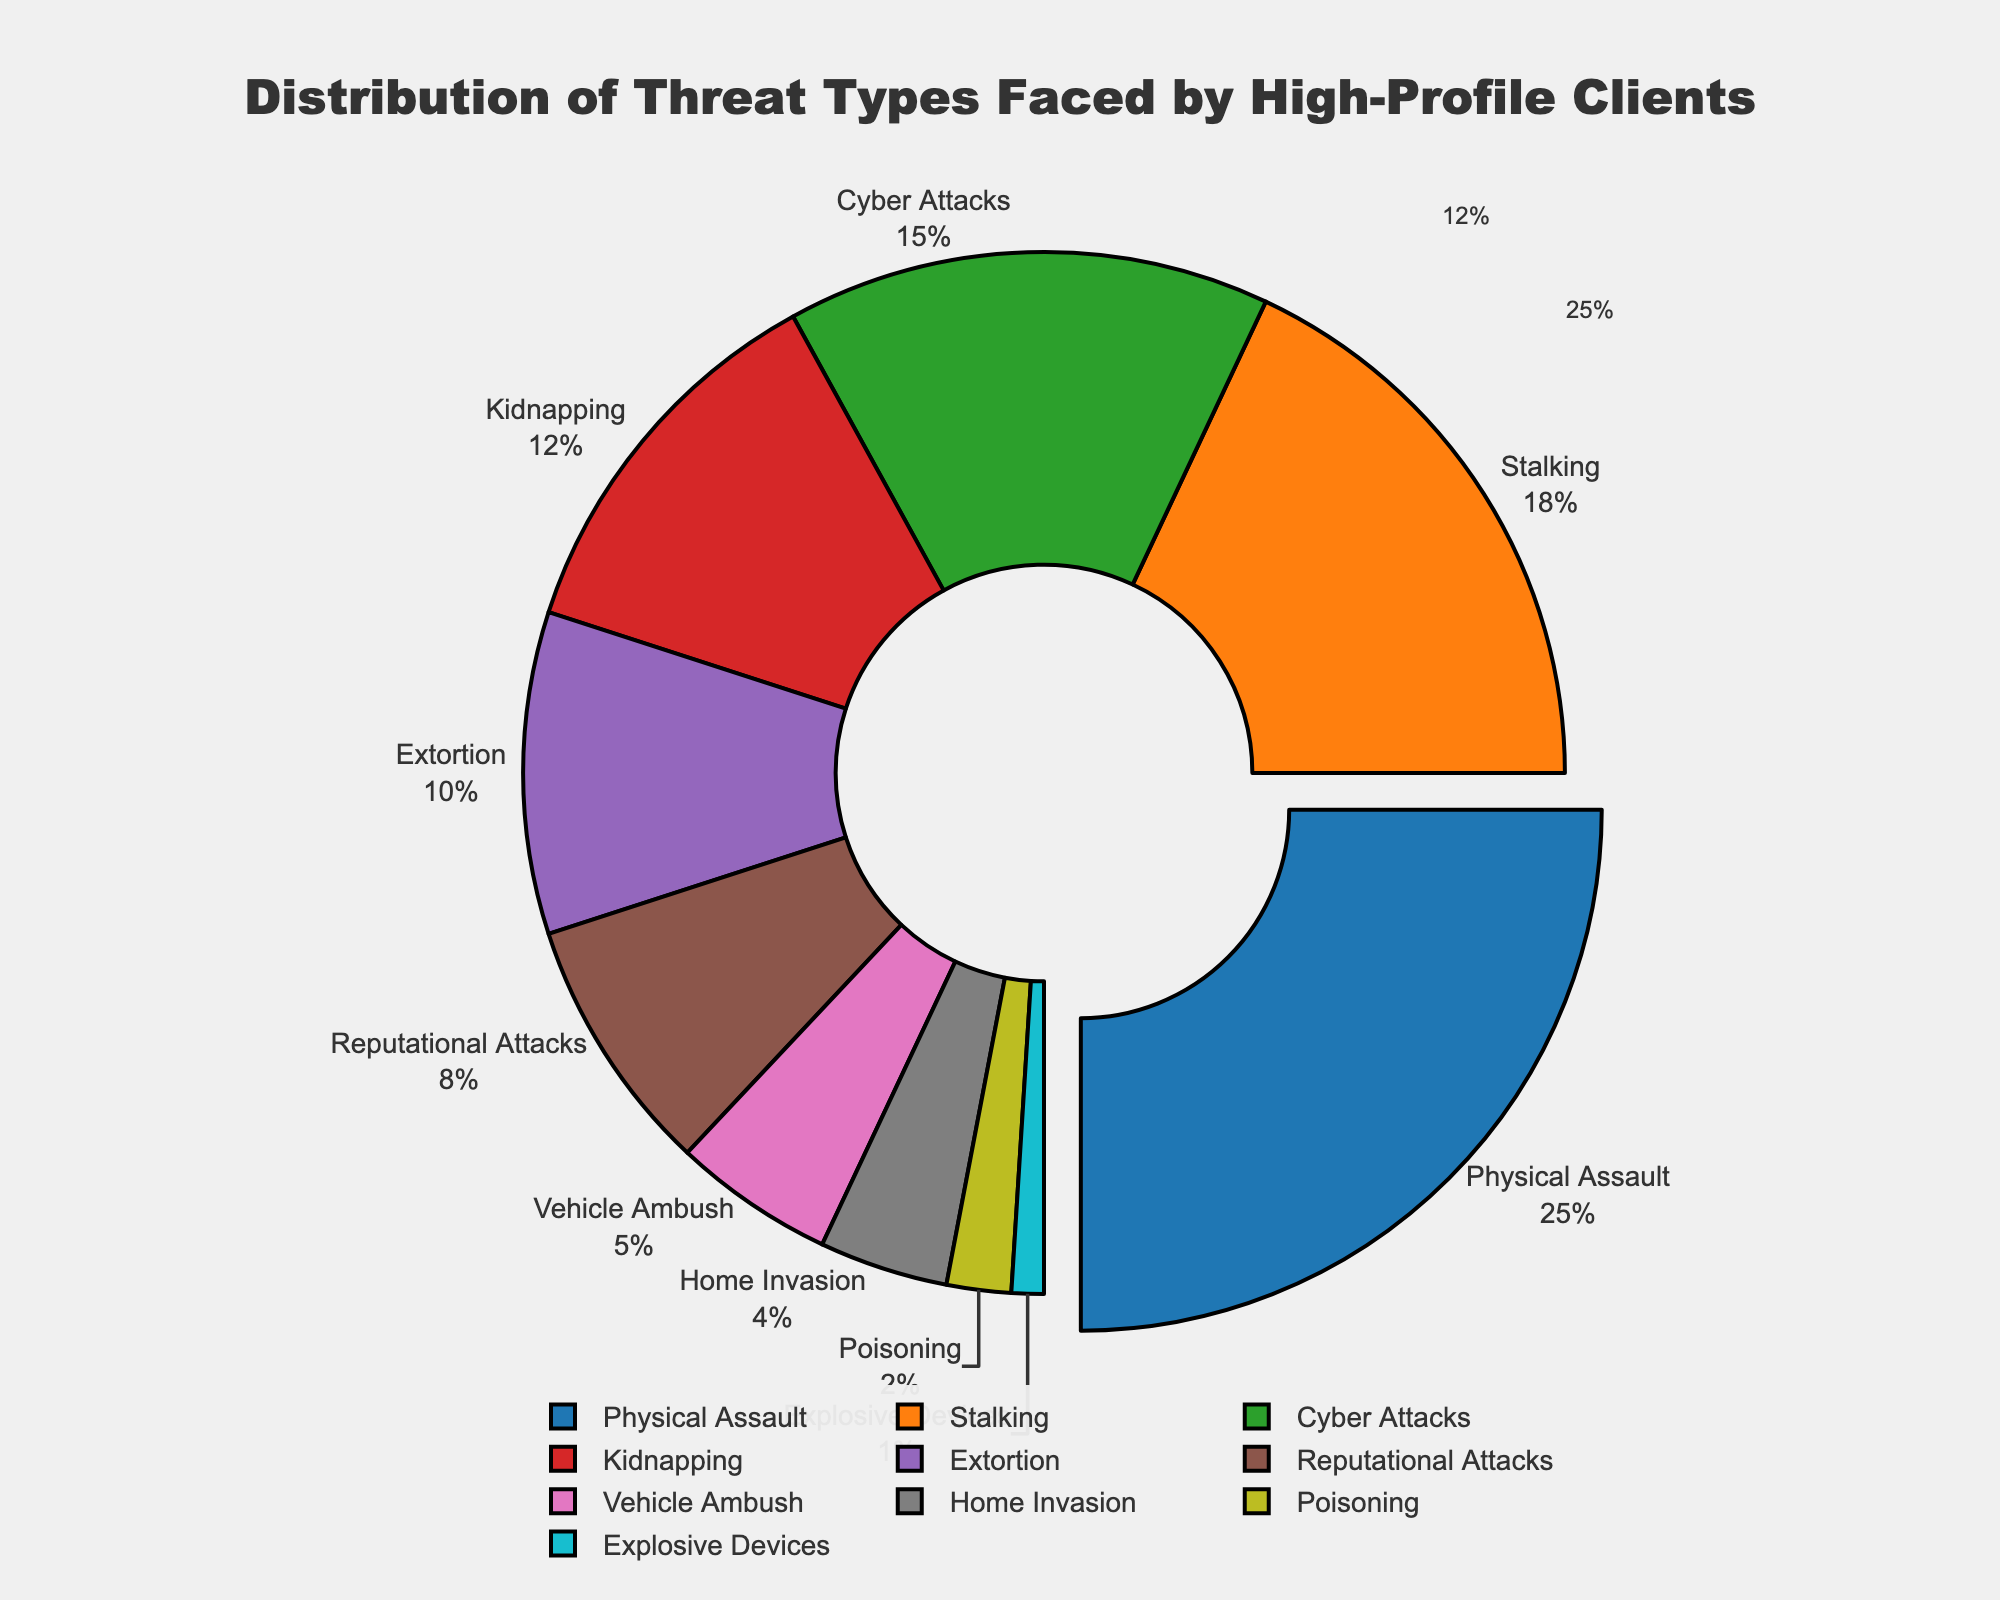Which threat type has the highest percentage? By observing the distribution, the segment with the largest size represents the threat type with the highest percentage.
Answer: Physical Assault What is the combined percentage of Cyber Attacks and Kidnapping? Add the percentages of Cyber Attacks (15%) and Kidnapping (12%): 15 + 12 = 27.
Answer: 27% How much greater is the percentage of Extortion compared to Vehicle Ambush? Subtract the percentage of Vehicle Ambush (5%) from Extortion (10%): 10 - 5 = 5.
Answer: 5% Which threat type has the smallest percentage? The smallest segment represents the threat type with the lowest percentage.
Answer: Explosive Devices Is the percentage of Stalking greater than double the percentage of Poisoning? Double the percentage of Poisoning (2%) is 4%. Comparing with Stalking (18%): 18 > 4.
Answer: Yes Which segment is labeled with a percentage in the range of 4-6%? Identify the segment showing a percentage between 4% and 6%.
Answer: Vehicle Ambush What is the total percentage of threats that are less than 5% each? Identify and sum the percentages for Home Invasion (4%), Poisoning (2%), and Explosive Devices (1%): 4 + 2 + 1 = 7.
Answer: 7% Which color represents the Reputational Attacks threat type? Find the label "Reputational Attacks" and observe the associated color of the segment.
Answer: Purple What is the difference in percentage between the highest and lowest threat types? Subtract the percentage of Explosive Devices (1%) from Physical Assault (25%): 25 - 1 = 24.
Answer: 24% 